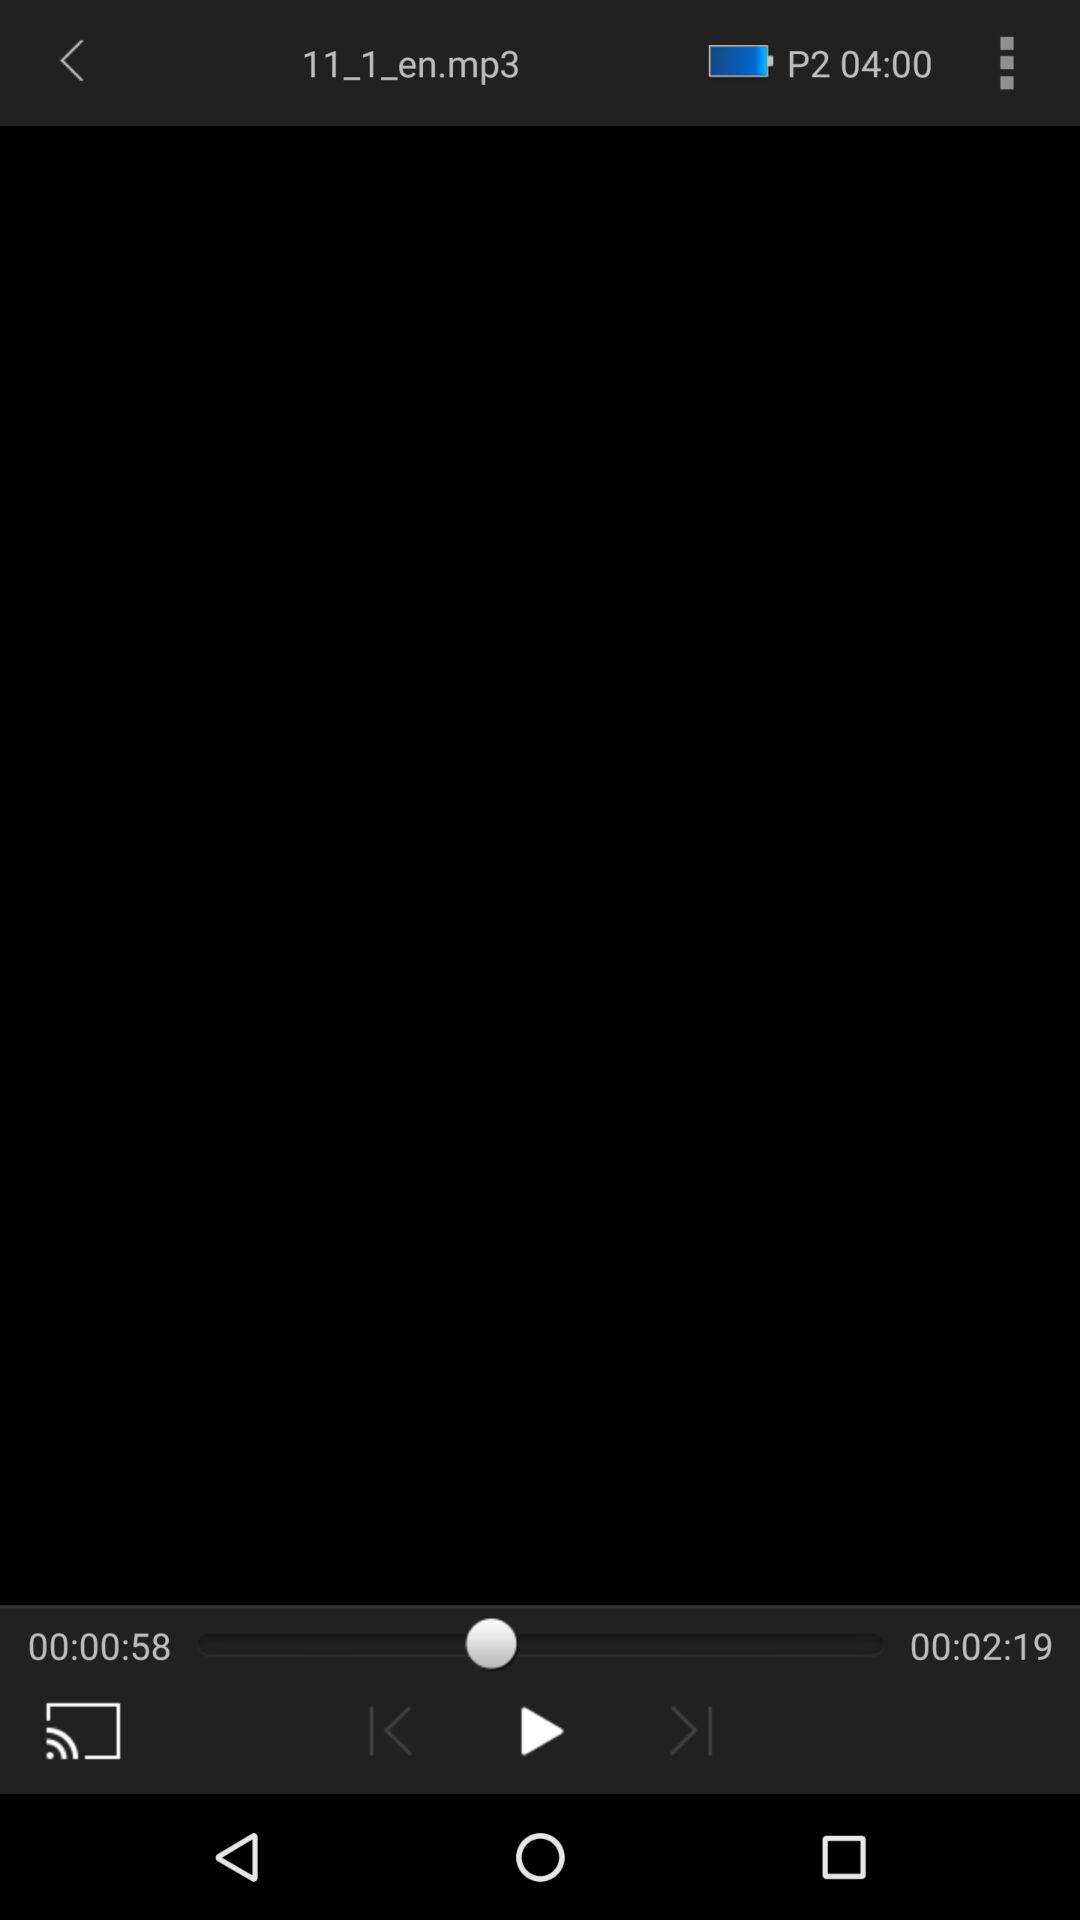What's the duration of the track? The duration of the track is 2 minutes 19 seconds. 